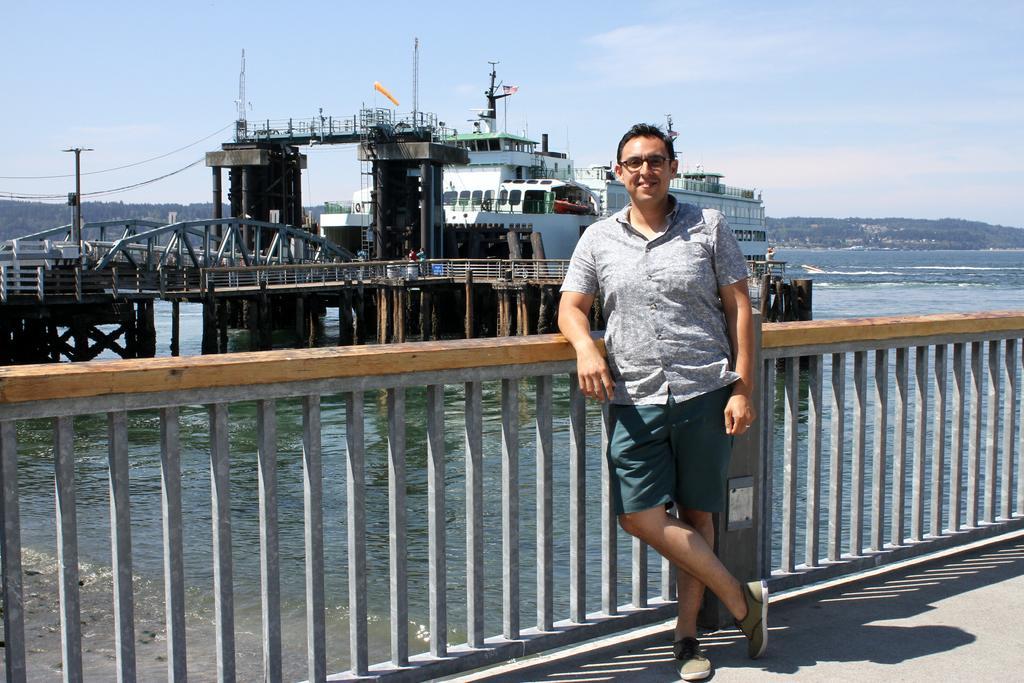Can you describe this image briefly? In this image a person is standing on the floor. He is keeping his hand on the fence. There is a bridge on the water. Behind there is a ship. Few persons are standing on the bridge. Background there is hill with trees. Top of the image there is sky. 